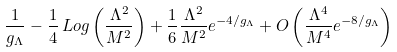Convert formula to latex. <formula><loc_0><loc_0><loc_500><loc_500>\frac { 1 } { g _ { \Lambda } } - \frac { 1 } { 4 } \, L o g \left ( \frac { \Lambda ^ { 2 } } { M ^ { 2 } } \right ) + \frac { 1 } { 6 } \frac { \Lambda ^ { 2 } } { M ^ { 2 } } e ^ { - 4 / g _ { \Lambda } } + O \left ( \frac { \Lambda ^ { 4 } } { M ^ { 4 } } e ^ { - 8 / g _ { \Lambda } } \right )</formula> 